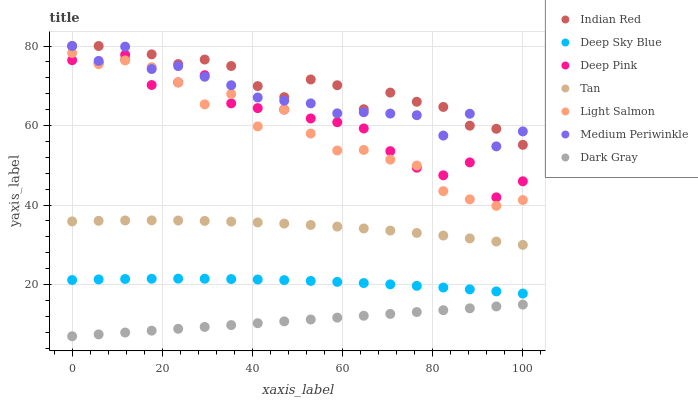Does Dark Gray have the minimum area under the curve?
Answer yes or no. Yes. Does Indian Red have the maximum area under the curve?
Answer yes or no. Yes. Does Deep Pink have the minimum area under the curve?
Answer yes or no. No. Does Deep Pink have the maximum area under the curve?
Answer yes or no. No. Is Dark Gray the smoothest?
Answer yes or no. Yes. Is Deep Pink the roughest?
Answer yes or no. Yes. Is Indian Red the smoothest?
Answer yes or no. No. Is Indian Red the roughest?
Answer yes or no. No. Does Dark Gray have the lowest value?
Answer yes or no. Yes. Does Deep Pink have the lowest value?
Answer yes or no. No. Does Medium Periwinkle have the highest value?
Answer yes or no. Yes. Does Deep Pink have the highest value?
Answer yes or no. No. Is Tan less than Light Salmon?
Answer yes or no. Yes. Is Indian Red greater than Dark Gray?
Answer yes or no. Yes. Does Indian Red intersect Medium Periwinkle?
Answer yes or no. Yes. Is Indian Red less than Medium Periwinkle?
Answer yes or no. No. Is Indian Red greater than Medium Periwinkle?
Answer yes or no. No. Does Tan intersect Light Salmon?
Answer yes or no. No. 